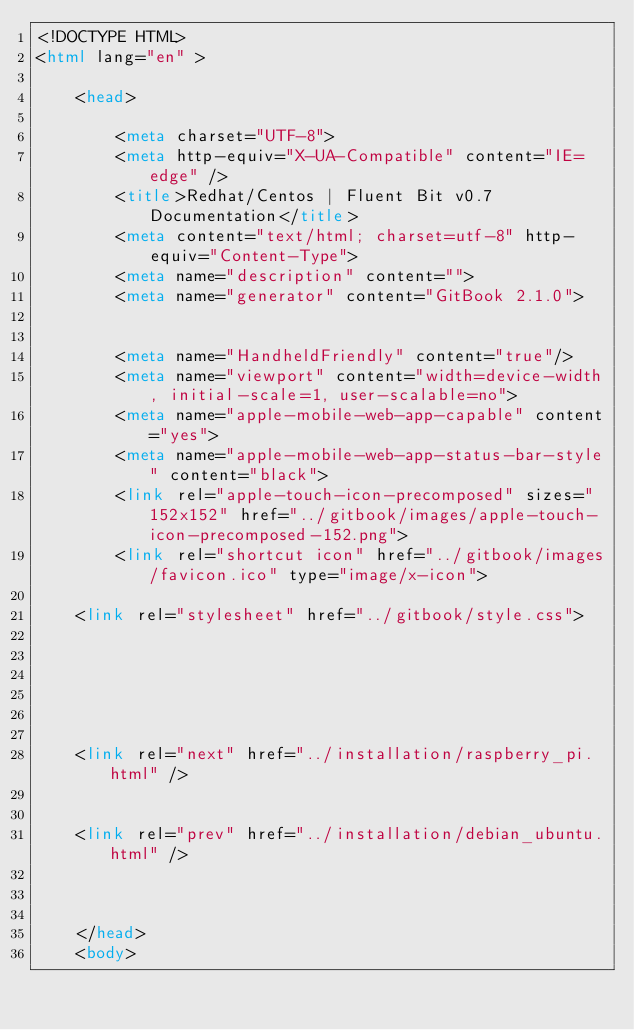<code> <loc_0><loc_0><loc_500><loc_500><_HTML_><!DOCTYPE HTML>
<html lang="en" >
    
    <head>
        
        <meta charset="UTF-8">
        <meta http-equiv="X-UA-Compatible" content="IE=edge" />
        <title>Redhat/Centos | Fluent Bit v0.7 Documentation</title>
        <meta content="text/html; charset=utf-8" http-equiv="Content-Type">
        <meta name="description" content="">
        <meta name="generator" content="GitBook 2.1.0">
        
        
        <meta name="HandheldFriendly" content="true"/>
        <meta name="viewport" content="width=device-width, initial-scale=1, user-scalable=no">
        <meta name="apple-mobile-web-app-capable" content="yes">
        <meta name="apple-mobile-web-app-status-bar-style" content="black">
        <link rel="apple-touch-icon-precomposed" sizes="152x152" href="../gitbook/images/apple-touch-icon-precomposed-152.png">
        <link rel="shortcut icon" href="../gitbook/images/favicon.ico" type="image/x-icon">
        
    <link rel="stylesheet" href="../gitbook/style.css">
    
    

        
    
    
    <link rel="next" href="../installation/raspberry_pi.html" />
    
    
    <link rel="prev" href="../installation/debian_ubuntu.html" />
    

        
    </head>
    <body>
        
        </code> 